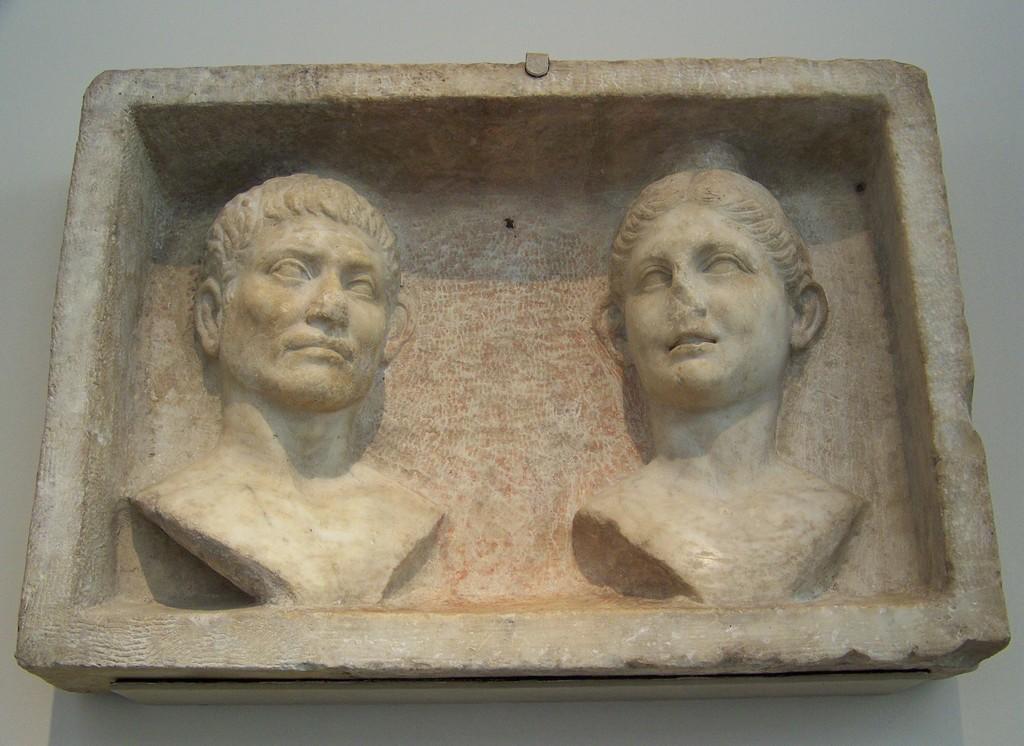Please provide a concise description of this image. In this image we can see a stone carving placed on the surface. 